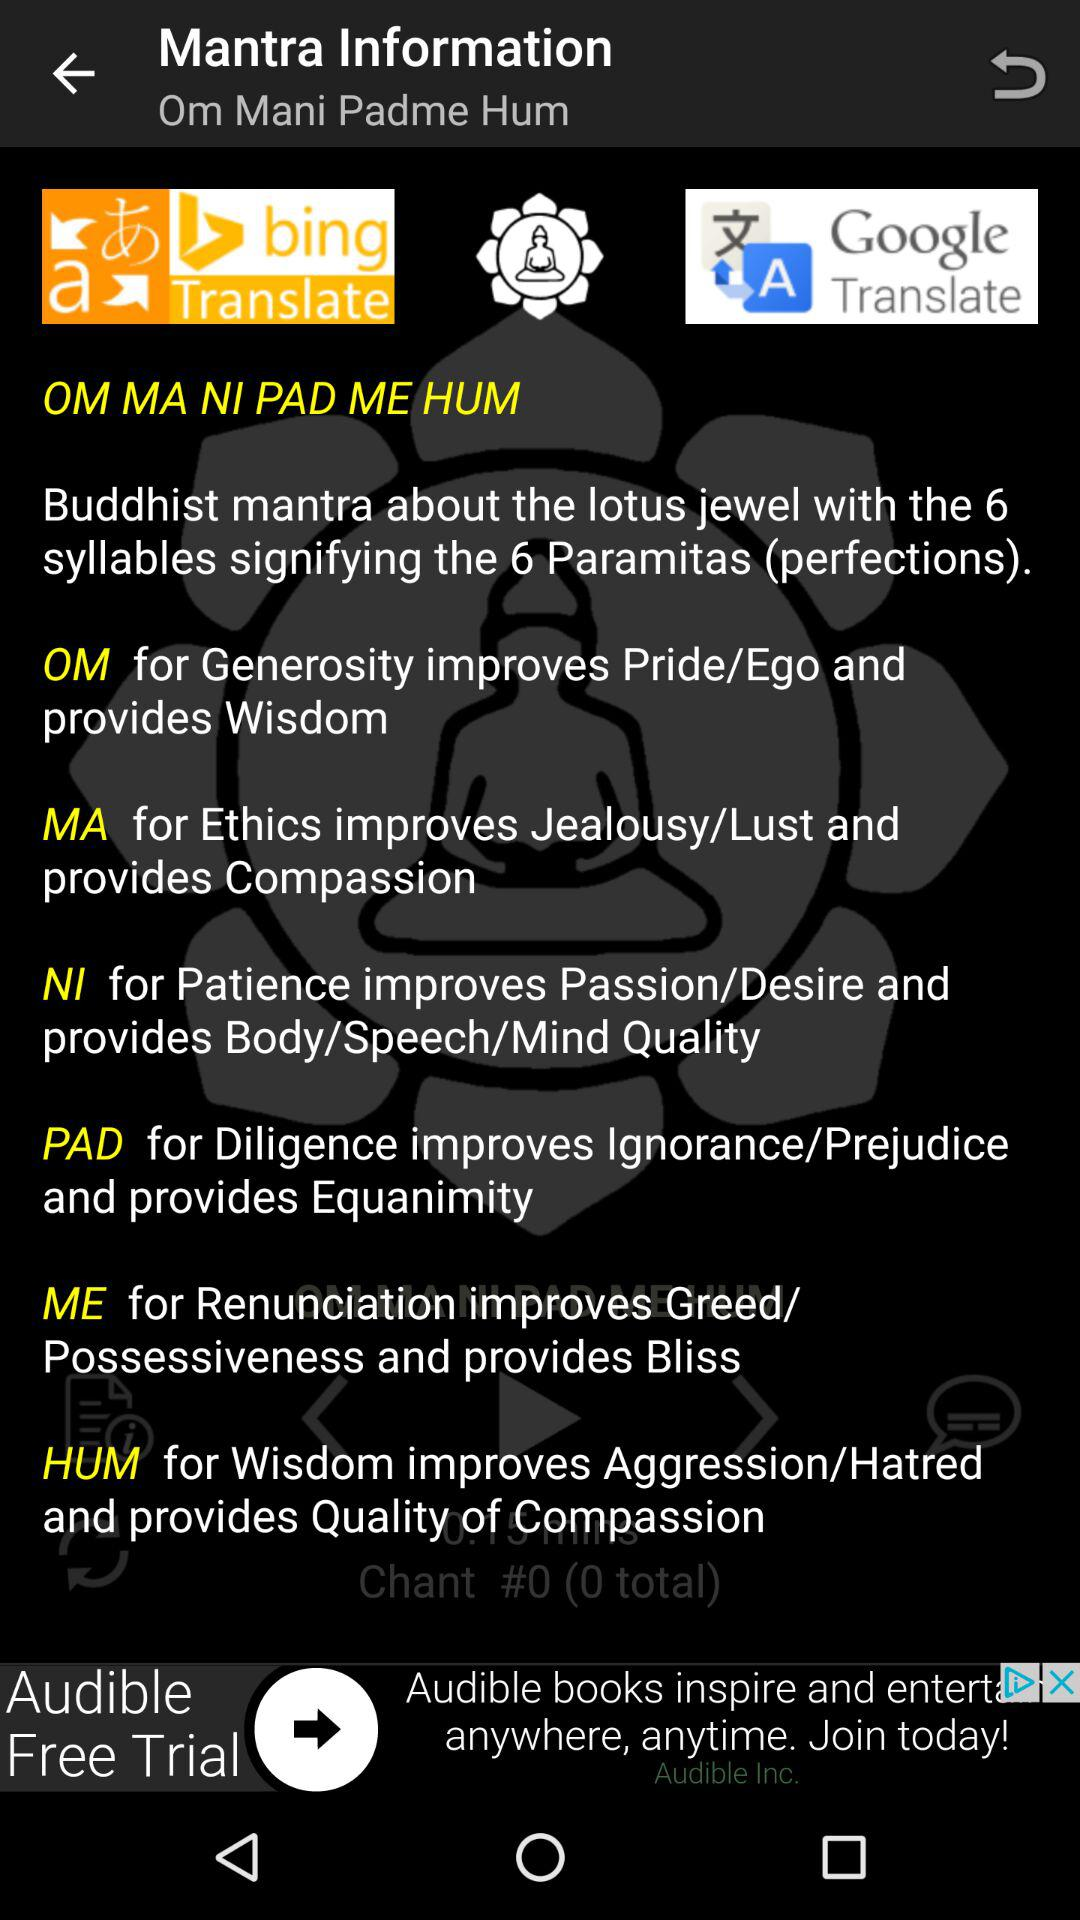How many syllables does the mantra have?
Answer the question using a single word or phrase. 6 